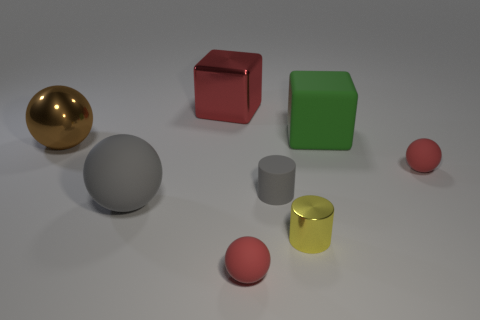What shape is the brown metal thing that is the same size as the red metal block?
Provide a succinct answer. Sphere. Are there any red things of the same shape as the large green object?
Offer a very short reply. Yes. What number of red objects have the same material as the tiny yellow thing?
Provide a succinct answer. 1. Do the tiny sphere that is in front of the tiny yellow metallic cylinder and the big green thing have the same material?
Keep it short and to the point. Yes. Are there more large gray objects that are in front of the big rubber cube than small shiny things that are on the right side of the tiny yellow metallic cylinder?
Keep it short and to the point. Yes. There is a gray thing that is the same size as the brown sphere; what is its material?
Make the answer very short. Rubber. How many other objects are there of the same material as the yellow object?
Your answer should be compact. 2. There is a rubber thing in front of the small yellow thing; is it the same shape as the tiny red object that is right of the green thing?
Offer a terse response. Yes. What number of other things are the same color as the shiny cylinder?
Your answer should be compact. 0. Does the large sphere on the right side of the big metallic sphere have the same material as the cube that is on the left side of the small yellow cylinder?
Your response must be concise. No. 